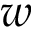<formula> <loc_0><loc_0><loc_500><loc_500>w</formula> 